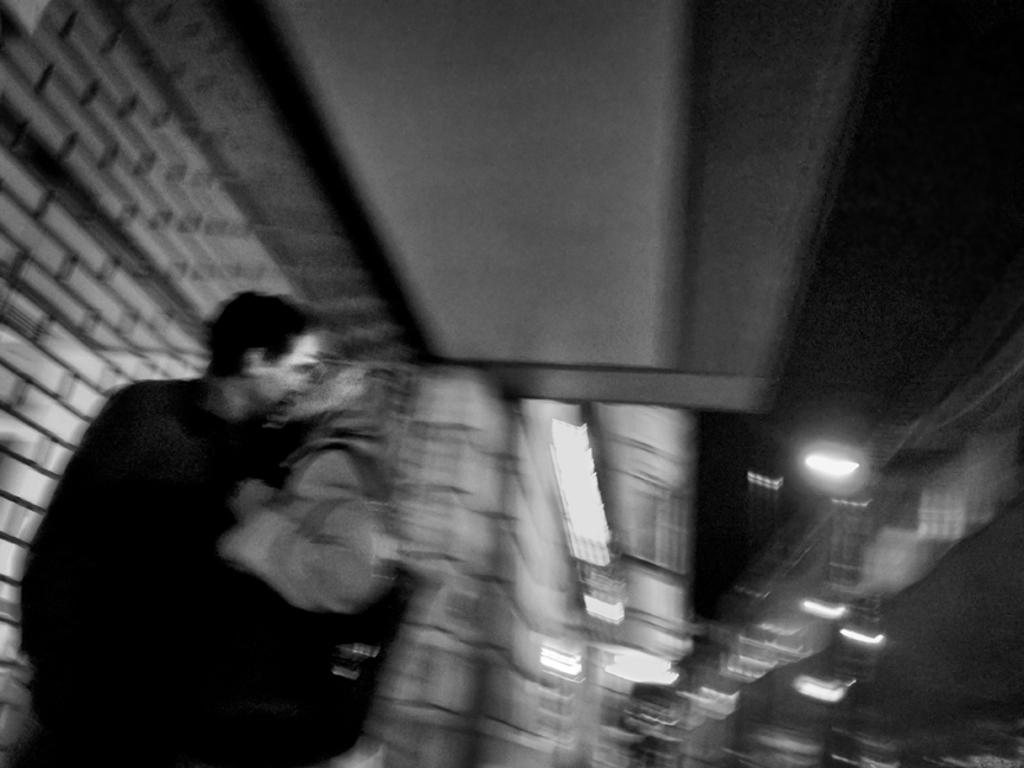What is present in the image? There is a person in the image. What else can be seen in the image besides the person? There are lights and a wall in the image. Can you describe the building that the person is jumping over in the image? There is no building or jumping person present in the image; it only features a person, lights, and a wall. What type of thunder can be heard in the image? There is no thunder present in the image, as it is a still image and not an audio recording. 